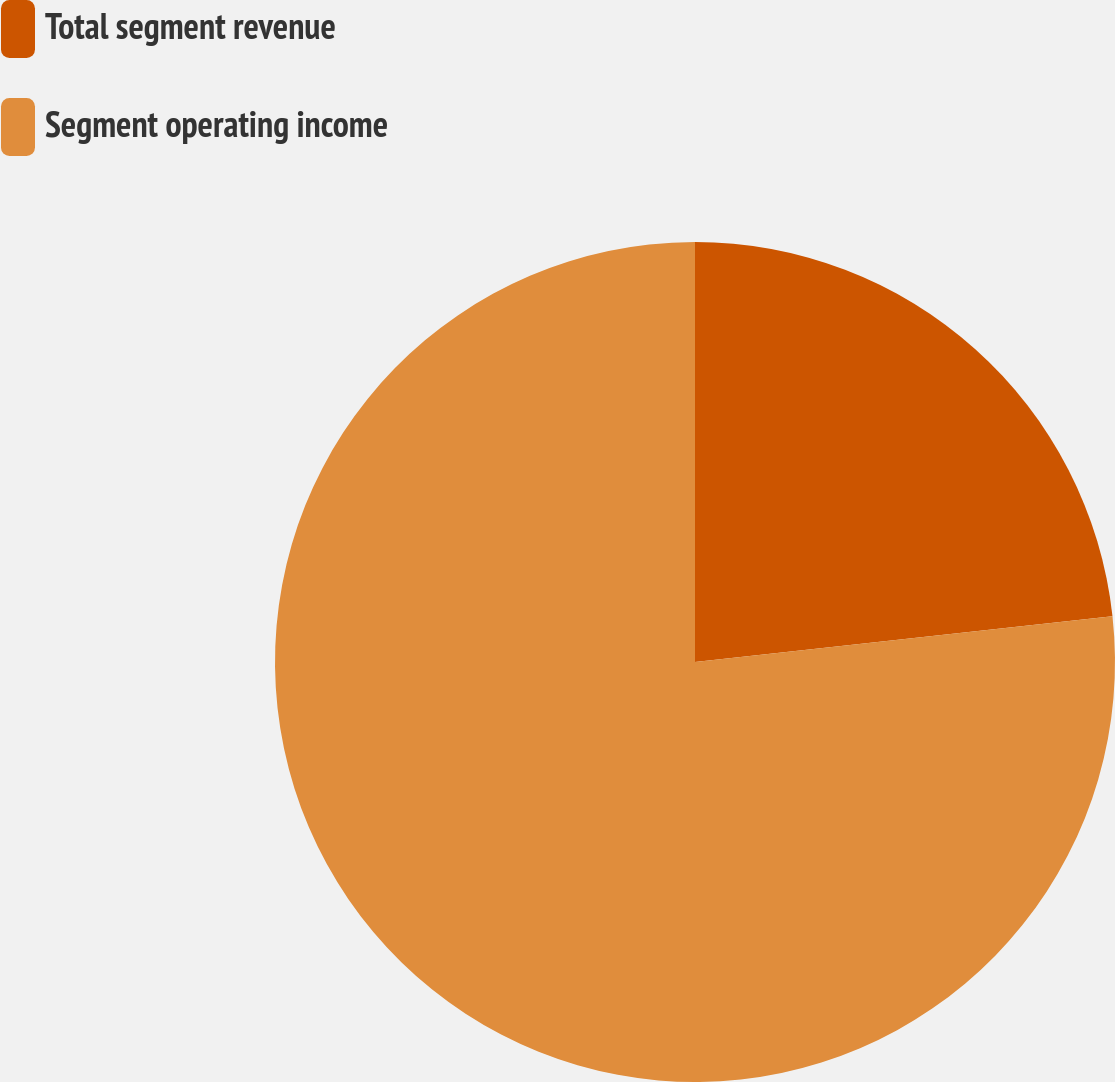<chart> <loc_0><loc_0><loc_500><loc_500><pie_chart><fcel>Total segment revenue<fcel>Segment operating income<nl><fcel>23.26%<fcel>76.74%<nl></chart> 